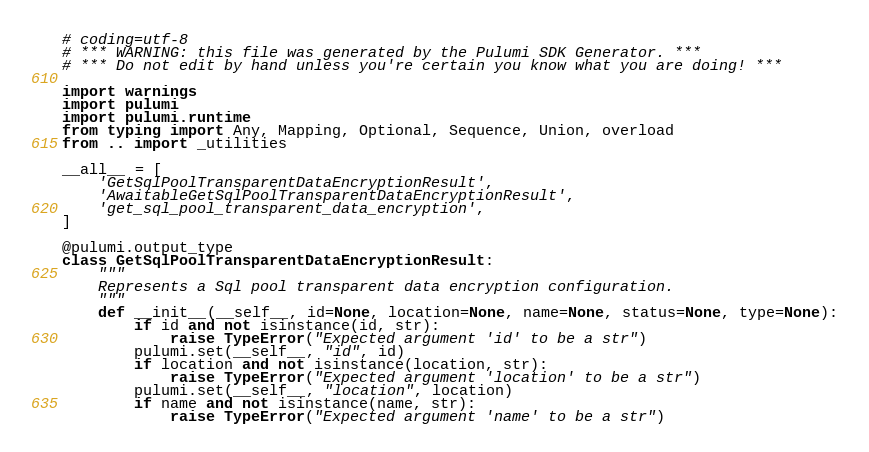Convert code to text. <code><loc_0><loc_0><loc_500><loc_500><_Python_># coding=utf-8
# *** WARNING: this file was generated by the Pulumi SDK Generator. ***
# *** Do not edit by hand unless you're certain you know what you are doing! ***

import warnings
import pulumi
import pulumi.runtime
from typing import Any, Mapping, Optional, Sequence, Union, overload
from .. import _utilities

__all__ = [
    'GetSqlPoolTransparentDataEncryptionResult',
    'AwaitableGetSqlPoolTransparentDataEncryptionResult',
    'get_sql_pool_transparent_data_encryption',
]

@pulumi.output_type
class GetSqlPoolTransparentDataEncryptionResult:
    """
    Represents a Sql pool transparent data encryption configuration.
    """
    def __init__(__self__, id=None, location=None, name=None, status=None, type=None):
        if id and not isinstance(id, str):
            raise TypeError("Expected argument 'id' to be a str")
        pulumi.set(__self__, "id", id)
        if location and not isinstance(location, str):
            raise TypeError("Expected argument 'location' to be a str")
        pulumi.set(__self__, "location", location)
        if name and not isinstance(name, str):
            raise TypeError("Expected argument 'name' to be a str")</code> 